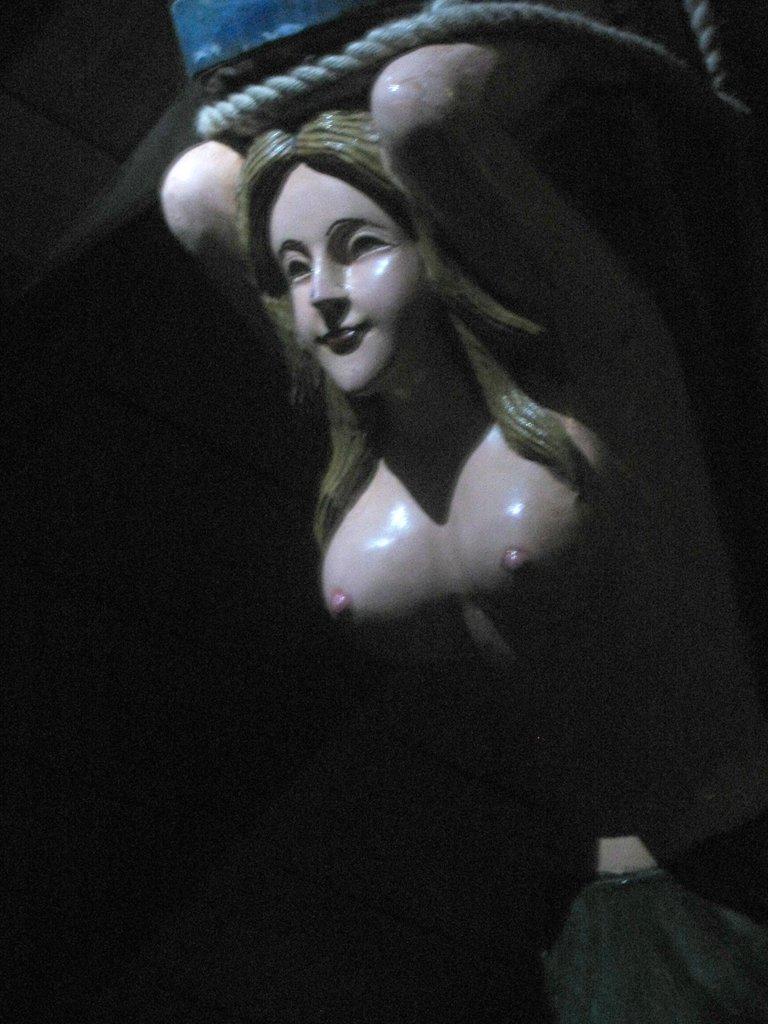Describe this image in one or two sentences. In this picture there is a statue in the center of the image and there is a rope at the top side of the image. 